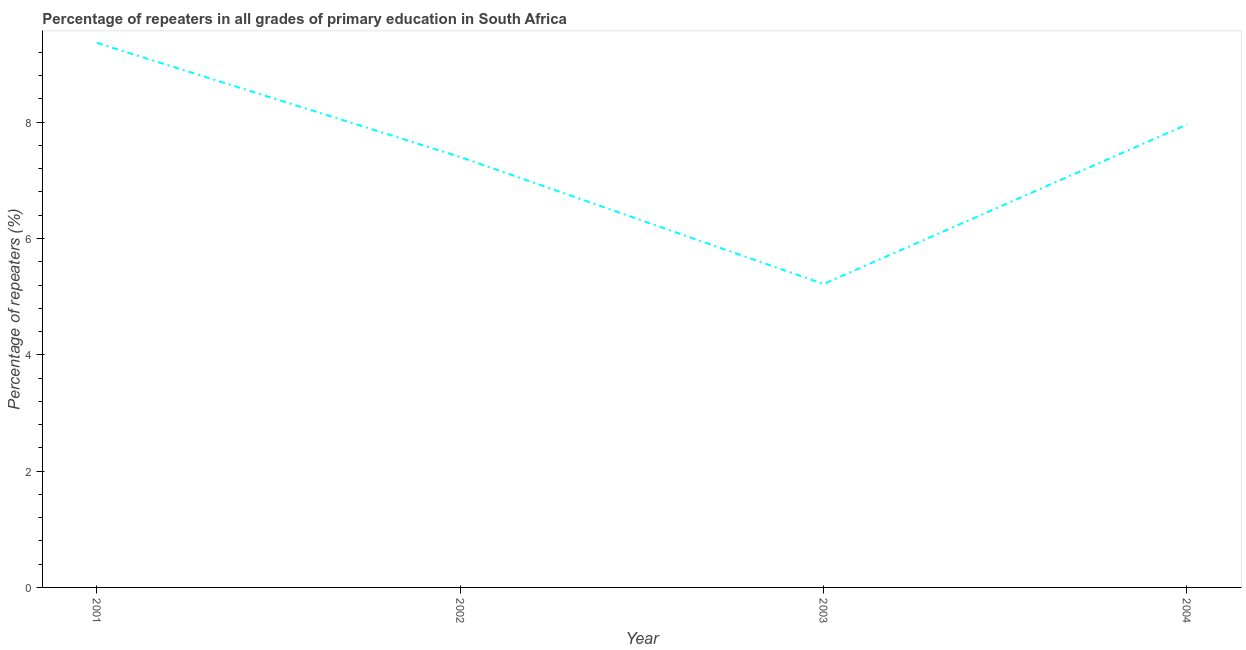What is the percentage of repeaters in primary education in 2001?
Give a very brief answer. 9.36. Across all years, what is the maximum percentage of repeaters in primary education?
Make the answer very short. 9.36. Across all years, what is the minimum percentage of repeaters in primary education?
Provide a succinct answer. 5.22. In which year was the percentage of repeaters in primary education maximum?
Your answer should be very brief. 2001. What is the sum of the percentage of repeaters in primary education?
Provide a short and direct response. 29.94. What is the difference between the percentage of repeaters in primary education in 2001 and 2003?
Offer a very short reply. 4.15. What is the average percentage of repeaters in primary education per year?
Ensure brevity in your answer.  7.49. What is the median percentage of repeaters in primary education?
Your response must be concise. 7.68. In how many years, is the percentage of repeaters in primary education greater than 6.8 %?
Your response must be concise. 3. Do a majority of the years between 2001 and 2004 (inclusive) have percentage of repeaters in primary education greater than 0.4 %?
Ensure brevity in your answer.  Yes. What is the ratio of the percentage of repeaters in primary education in 2002 to that in 2004?
Provide a short and direct response. 0.93. What is the difference between the highest and the second highest percentage of repeaters in primary education?
Your answer should be compact. 1.4. What is the difference between the highest and the lowest percentage of repeaters in primary education?
Keep it short and to the point. 4.15. Does the percentage of repeaters in primary education monotonically increase over the years?
Keep it short and to the point. No. What is the difference between two consecutive major ticks on the Y-axis?
Provide a short and direct response. 2. Are the values on the major ticks of Y-axis written in scientific E-notation?
Keep it short and to the point. No. Does the graph contain any zero values?
Make the answer very short. No. Does the graph contain grids?
Ensure brevity in your answer.  No. What is the title of the graph?
Offer a very short reply. Percentage of repeaters in all grades of primary education in South Africa. What is the label or title of the X-axis?
Keep it short and to the point. Year. What is the label or title of the Y-axis?
Make the answer very short. Percentage of repeaters (%). What is the Percentage of repeaters (%) of 2001?
Keep it short and to the point. 9.36. What is the Percentage of repeaters (%) of 2002?
Offer a terse response. 7.4. What is the Percentage of repeaters (%) in 2003?
Ensure brevity in your answer.  5.22. What is the Percentage of repeaters (%) of 2004?
Your response must be concise. 7.96. What is the difference between the Percentage of repeaters (%) in 2001 and 2002?
Offer a very short reply. 1.96. What is the difference between the Percentage of repeaters (%) in 2001 and 2003?
Offer a very short reply. 4.15. What is the difference between the Percentage of repeaters (%) in 2001 and 2004?
Your answer should be compact. 1.4. What is the difference between the Percentage of repeaters (%) in 2002 and 2003?
Keep it short and to the point. 2.18. What is the difference between the Percentage of repeaters (%) in 2002 and 2004?
Ensure brevity in your answer.  -0.56. What is the difference between the Percentage of repeaters (%) in 2003 and 2004?
Offer a very short reply. -2.74. What is the ratio of the Percentage of repeaters (%) in 2001 to that in 2002?
Your response must be concise. 1.26. What is the ratio of the Percentage of repeaters (%) in 2001 to that in 2003?
Keep it short and to the point. 1.79. What is the ratio of the Percentage of repeaters (%) in 2001 to that in 2004?
Provide a short and direct response. 1.18. What is the ratio of the Percentage of repeaters (%) in 2002 to that in 2003?
Offer a terse response. 1.42. What is the ratio of the Percentage of repeaters (%) in 2003 to that in 2004?
Provide a short and direct response. 0.66. 